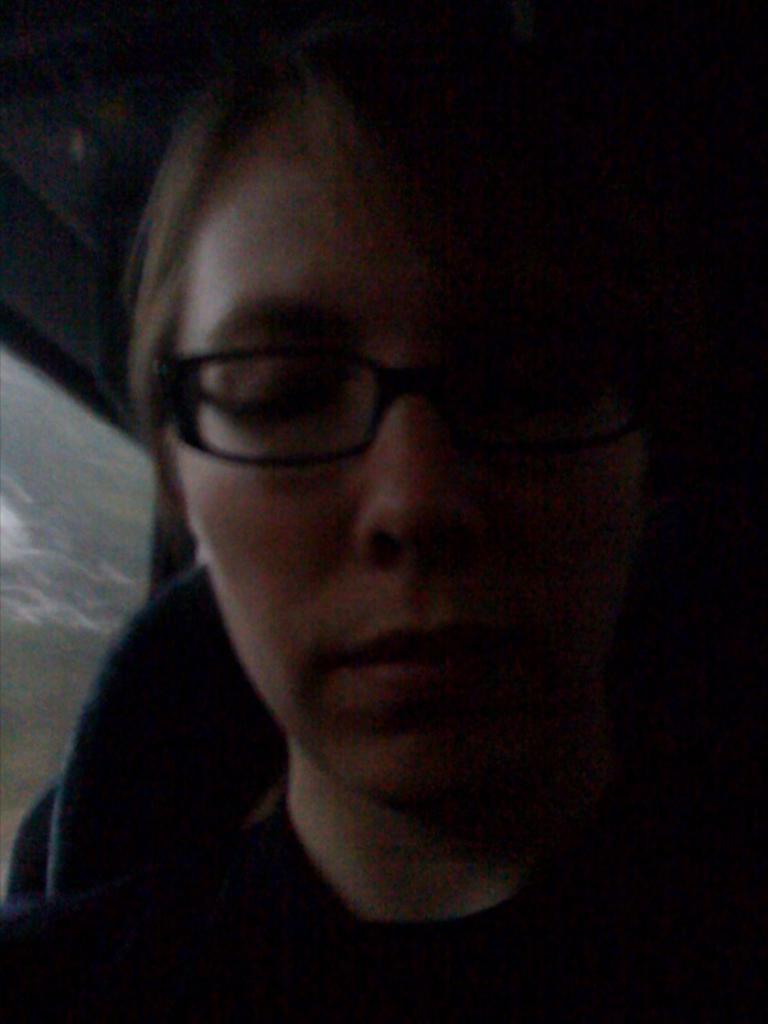What can be seen in the image? There is a person in the image. Can you describe the person's appearance? The person is wearing glasses. What else is present in the image? There is a seat and a glass object on the left side of the image. What type of texture can be felt on the tank in the image? There is no tank present in the image, so it is not possible to determine its texture. 